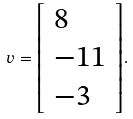Convert formula to latex. <formula><loc_0><loc_0><loc_500><loc_500>v = { \left [ \begin{array} { l } { 8 } \\ { - 1 1 } \\ { - 3 } \end{array} \right ] } .</formula> 